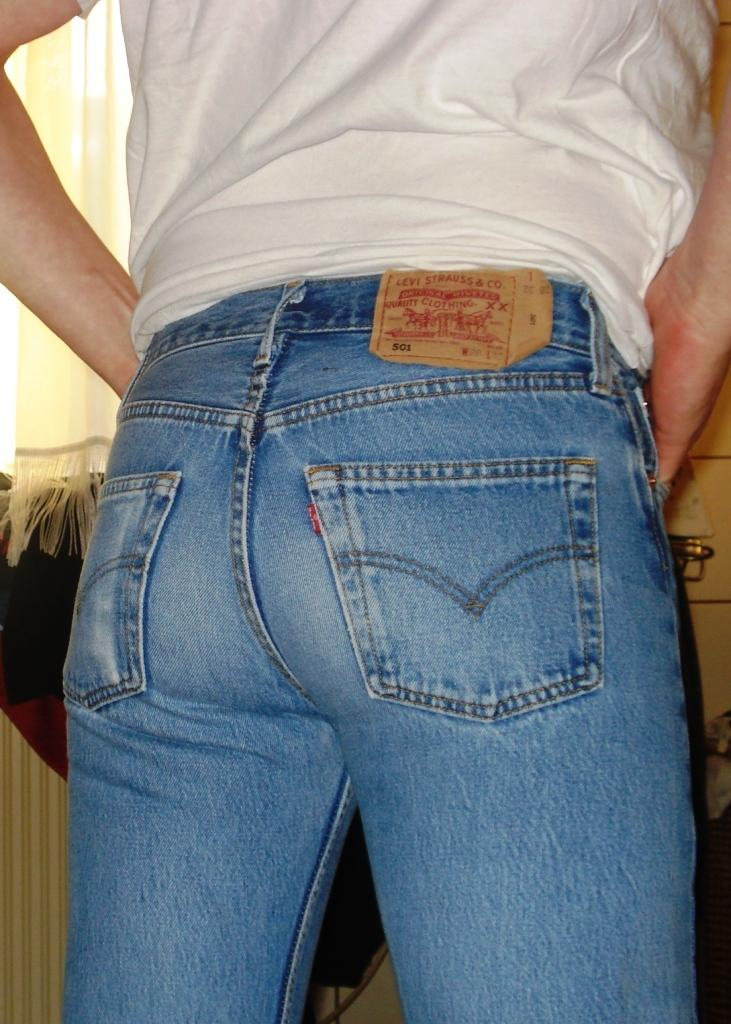What is the main subject of the image? There is a person in the image. What type of clothing is the person wearing? The person is wearing jeans and a white top. What can be seen in the background of the image? There is a curtain visible in the image, and there are objects present in the background. How many giants can be seen interacting with the van in the image? There are no giants or vans present in the image. What form does the person take in the image? The person is depicted in their natural human form in the image. 